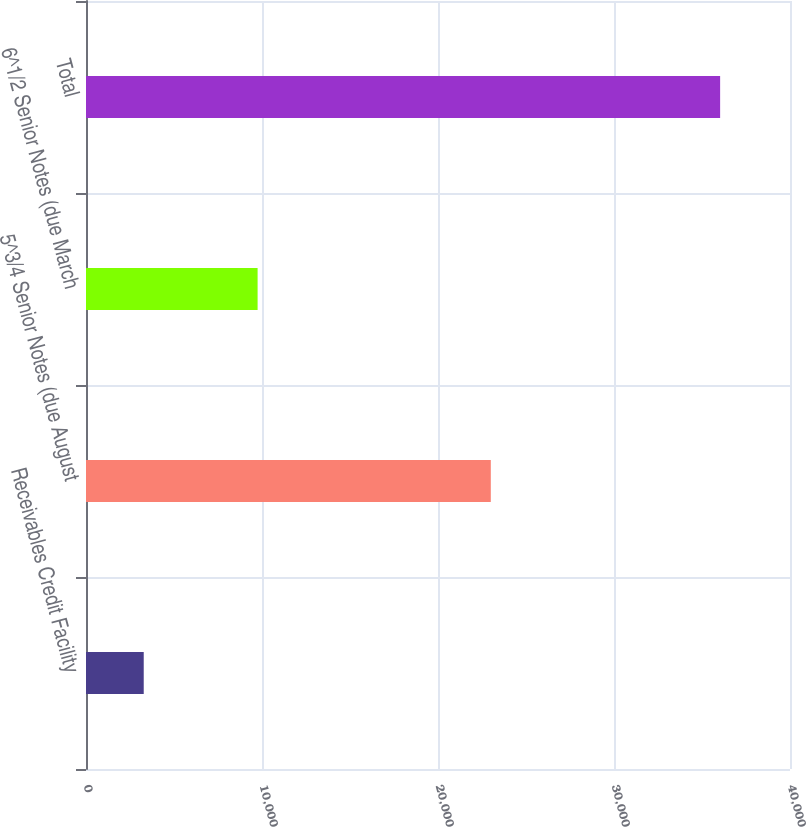Convert chart to OTSL. <chart><loc_0><loc_0><loc_500><loc_500><bar_chart><fcel>Receivables Credit Facility<fcel>5^3/4 Senior Notes (due August<fcel>6^1/2 Senior Notes (due March<fcel>Total<nl><fcel>3280<fcel>23000<fcel>9750<fcel>36030<nl></chart> 